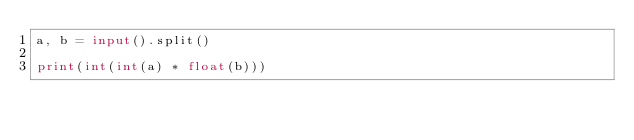Convert code to text. <code><loc_0><loc_0><loc_500><loc_500><_Python_>a, b = input().split()

print(int(int(a) * float(b)))
</code> 